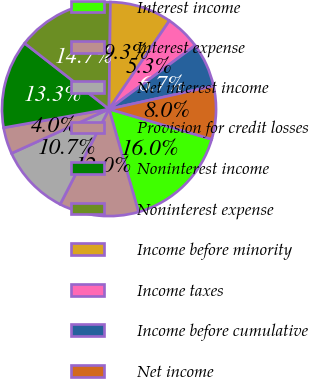Convert chart. <chart><loc_0><loc_0><loc_500><loc_500><pie_chart><fcel>Interest income<fcel>Interest expense<fcel>Net interest income<fcel>Provision for credit losses<fcel>Noninterest income<fcel>Noninterest expense<fcel>Income before minority<fcel>Income taxes<fcel>Income before cumulative<fcel>Net income<nl><fcel>16.0%<fcel>12.0%<fcel>10.67%<fcel>4.0%<fcel>13.33%<fcel>14.66%<fcel>9.33%<fcel>5.34%<fcel>6.67%<fcel>8.0%<nl></chart> 